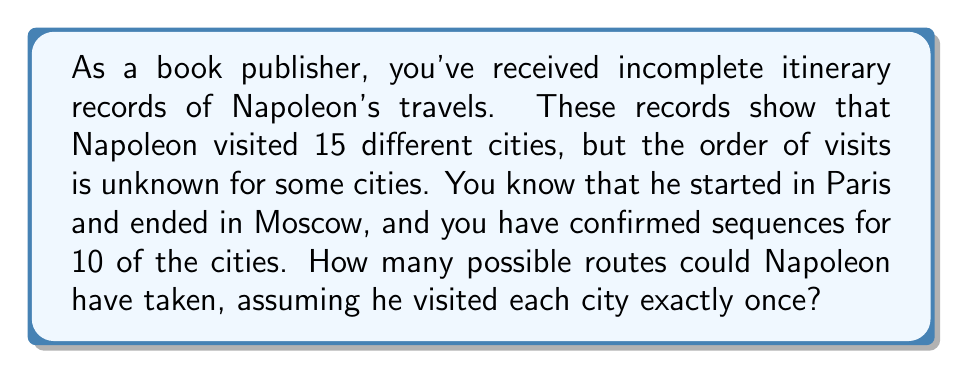What is the answer to this math problem? Let's approach this step-by-step:

1) We know Napoleon visited 15 cities in total.

2) We have confirmed sequences for 10 cities, including the start (Paris) and end (Moscow).

3) This means there are 5 cities whose positions in the sequence are unknown.

4) The problem now becomes: in how many ways can we arrange these 5 cities within the gaps of the known sequence?

5) This is a permutation problem. The number of permutations of n distinct objects is given by n!

6) In this case, n = 5 (the number of cities with unknown positions)

7) Therefore, the number of possible routes is:

   $$5! = 5 \times 4 \times 3 \times 2 \times 1 = 120$$

8) This means there are 120 possible ways to arrange the 5 unknown cities within the gaps of the known sequence.

This solution assumes that the 10 known cities form a single continuous sequence with gaps, rather than multiple disconnected sequences. If there were multiple known sequences, the problem would be more complex and would require additional information about the number and size of these sequences.
Answer: 120 